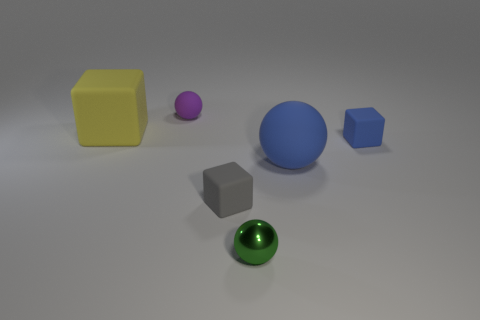Are there any large balls that have the same material as the tiny blue thing?
Provide a succinct answer. Yes. What material is the tiny sphere in front of the big thing that is on the left side of the tiny gray matte cube made of?
Your answer should be very brief. Metal. How many other big things have the same shape as the gray rubber thing?
Provide a succinct answer. 1. The green object is what shape?
Your response must be concise. Sphere. Is the number of big blue metallic cubes less than the number of big yellow objects?
Provide a succinct answer. Yes. There is a tiny green object that is the same shape as the large blue matte thing; what is its material?
Your answer should be very brief. Metal. Is the number of big blue matte balls greater than the number of yellow metal things?
Keep it short and to the point. Yes. How many other things are the same color as the big matte sphere?
Your response must be concise. 1. Are the small gray cube and the small sphere that is to the right of the purple matte sphere made of the same material?
Your answer should be compact. No. What number of large spheres are in front of the metallic sphere in front of the sphere that is on the left side of the small shiny sphere?
Offer a terse response. 0. 